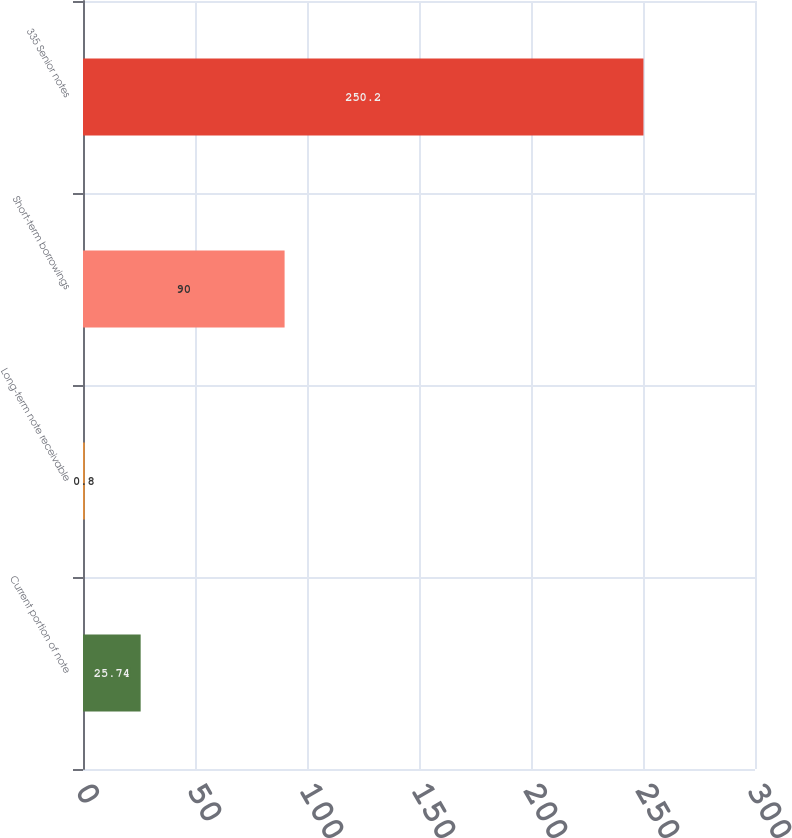Convert chart to OTSL. <chart><loc_0><loc_0><loc_500><loc_500><bar_chart><fcel>Current portion of note<fcel>Long-term note receivable<fcel>Short-term borrowings<fcel>335 Senior notes<nl><fcel>25.74<fcel>0.8<fcel>90<fcel>250.2<nl></chart> 